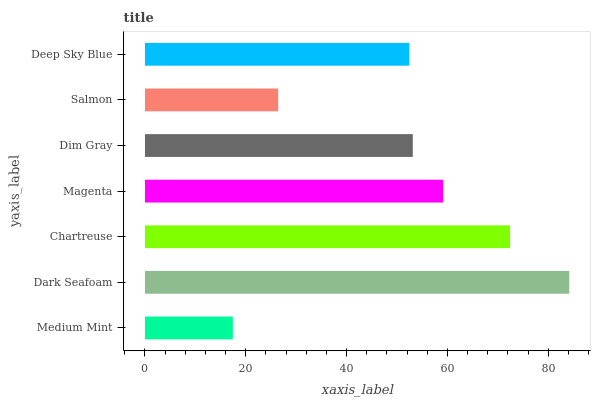Is Medium Mint the minimum?
Answer yes or no. Yes. Is Dark Seafoam the maximum?
Answer yes or no. Yes. Is Chartreuse the minimum?
Answer yes or no. No. Is Chartreuse the maximum?
Answer yes or no. No. Is Dark Seafoam greater than Chartreuse?
Answer yes or no. Yes. Is Chartreuse less than Dark Seafoam?
Answer yes or no. Yes. Is Chartreuse greater than Dark Seafoam?
Answer yes or no. No. Is Dark Seafoam less than Chartreuse?
Answer yes or no. No. Is Dim Gray the high median?
Answer yes or no. Yes. Is Dim Gray the low median?
Answer yes or no. Yes. Is Deep Sky Blue the high median?
Answer yes or no. No. Is Chartreuse the low median?
Answer yes or no. No. 